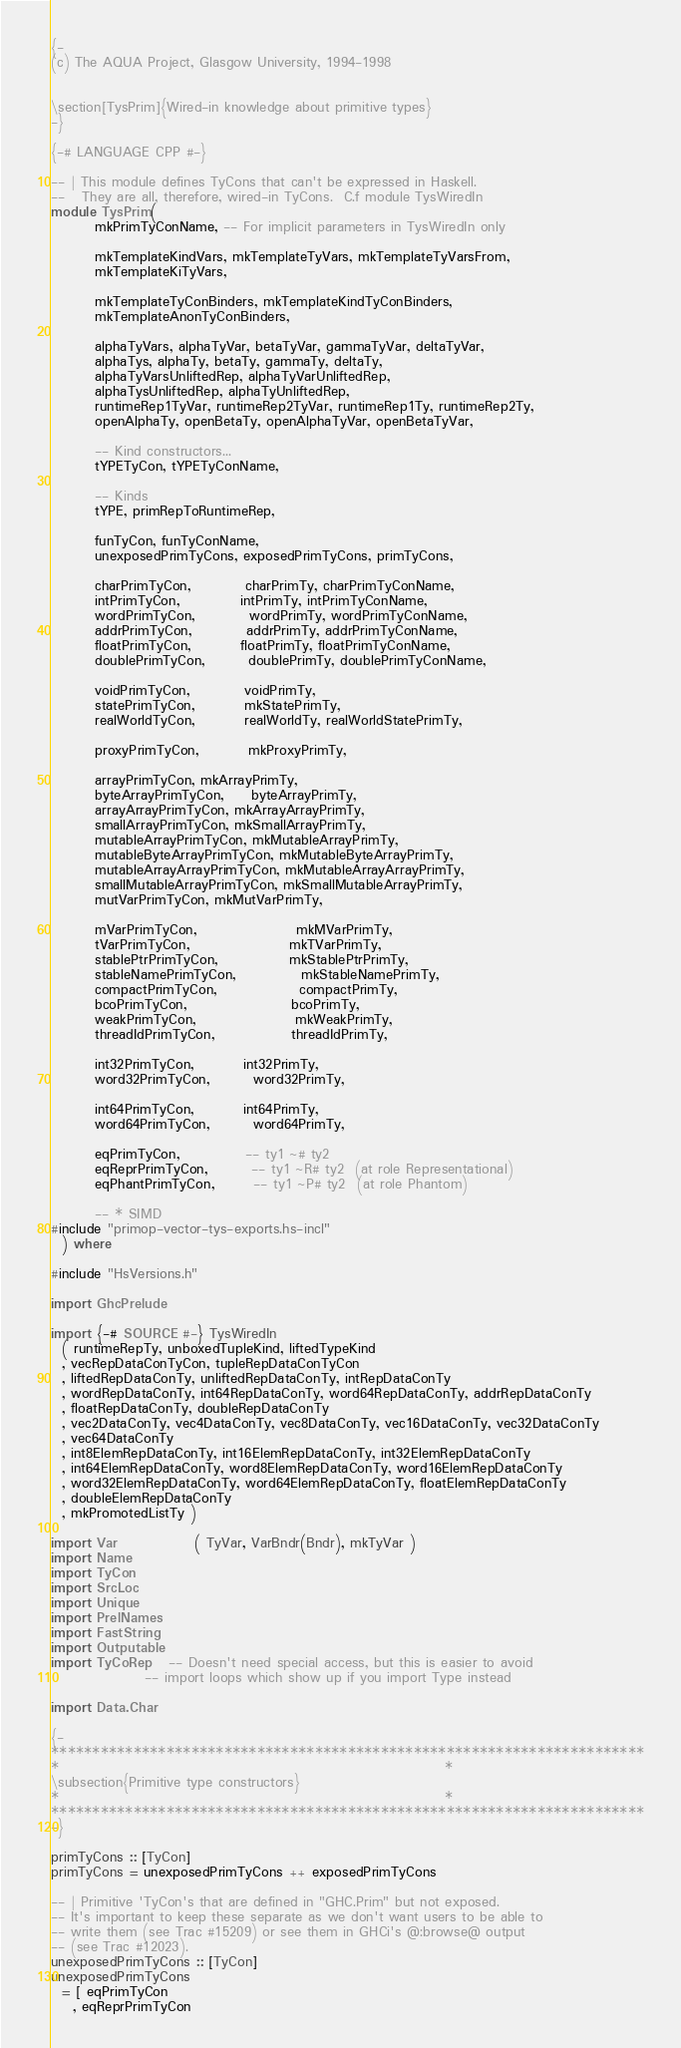Convert code to text. <code><loc_0><loc_0><loc_500><loc_500><_Haskell_>{-
(c) The AQUA Project, Glasgow University, 1994-1998


\section[TysPrim]{Wired-in knowledge about primitive types}
-}

{-# LANGUAGE CPP #-}

-- | This module defines TyCons that can't be expressed in Haskell.
--   They are all, therefore, wired-in TyCons.  C.f module TysWiredIn
module TysPrim(
        mkPrimTyConName, -- For implicit parameters in TysWiredIn only

        mkTemplateKindVars, mkTemplateTyVars, mkTemplateTyVarsFrom,
        mkTemplateKiTyVars,

        mkTemplateTyConBinders, mkTemplateKindTyConBinders,
        mkTemplateAnonTyConBinders,

        alphaTyVars, alphaTyVar, betaTyVar, gammaTyVar, deltaTyVar,
        alphaTys, alphaTy, betaTy, gammaTy, deltaTy,
        alphaTyVarsUnliftedRep, alphaTyVarUnliftedRep,
        alphaTysUnliftedRep, alphaTyUnliftedRep,
        runtimeRep1TyVar, runtimeRep2TyVar, runtimeRep1Ty, runtimeRep2Ty,
        openAlphaTy, openBetaTy, openAlphaTyVar, openBetaTyVar,

        -- Kind constructors...
        tYPETyCon, tYPETyConName,

        -- Kinds
        tYPE, primRepToRuntimeRep,

        funTyCon, funTyConName,
        unexposedPrimTyCons, exposedPrimTyCons, primTyCons,

        charPrimTyCon,          charPrimTy, charPrimTyConName,
        intPrimTyCon,           intPrimTy, intPrimTyConName,
        wordPrimTyCon,          wordPrimTy, wordPrimTyConName,
        addrPrimTyCon,          addrPrimTy, addrPrimTyConName,
        floatPrimTyCon,         floatPrimTy, floatPrimTyConName,
        doublePrimTyCon,        doublePrimTy, doublePrimTyConName,

        voidPrimTyCon,          voidPrimTy,
        statePrimTyCon,         mkStatePrimTy,
        realWorldTyCon,         realWorldTy, realWorldStatePrimTy,

        proxyPrimTyCon,         mkProxyPrimTy,

        arrayPrimTyCon, mkArrayPrimTy,
        byteArrayPrimTyCon,     byteArrayPrimTy,
        arrayArrayPrimTyCon, mkArrayArrayPrimTy,
        smallArrayPrimTyCon, mkSmallArrayPrimTy,
        mutableArrayPrimTyCon, mkMutableArrayPrimTy,
        mutableByteArrayPrimTyCon, mkMutableByteArrayPrimTy,
        mutableArrayArrayPrimTyCon, mkMutableArrayArrayPrimTy,
        smallMutableArrayPrimTyCon, mkSmallMutableArrayPrimTy,
        mutVarPrimTyCon, mkMutVarPrimTy,

        mVarPrimTyCon,                  mkMVarPrimTy,
        tVarPrimTyCon,                  mkTVarPrimTy,
        stablePtrPrimTyCon,             mkStablePtrPrimTy,
        stableNamePrimTyCon,            mkStableNamePrimTy,
        compactPrimTyCon,               compactPrimTy,
        bcoPrimTyCon,                   bcoPrimTy,
        weakPrimTyCon,                  mkWeakPrimTy,
        threadIdPrimTyCon,              threadIdPrimTy,

        int32PrimTyCon,         int32PrimTy,
        word32PrimTyCon,        word32PrimTy,

        int64PrimTyCon,         int64PrimTy,
        word64PrimTyCon,        word64PrimTy,

        eqPrimTyCon,            -- ty1 ~# ty2
        eqReprPrimTyCon,        -- ty1 ~R# ty2  (at role Representational)
        eqPhantPrimTyCon,       -- ty1 ~P# ty2  (at role Phantom)

        -- * SIMD
#include "primop-vector-tys-exports.hs-incl"
  ) where

#include "HsVersions.h"

import GhcPrelude

import {-# SOURCE #-} TysWiredIn
  ( runtimeRepTy, unboxedTupleKind, liftedTypeKind
  , vecRepDataConTyCon, tupleRepDataConTyCon
  , liftedRepDataConTy, unliftedRepDataConTy, intRepDataConTy
  , wordRepDataConTy, int64RepDataConTy, word64RepDataConTy, addrRepDataConTy
  , floatRepDataConTy, doubleRepDataConTy
  , vec2DataConTy, vec4DataConTy, vec8DataConTy, vec16DataConTy, vec32DataConTy
  , vec64DataConTy
  , int8ElemRepDataConTy, int16ElemRepDataConTy, int32ElemRepDataConTy
  , int64ElemRepDataConTy, word8ElemRepDataConTy, word16ElemRepDataConTy
  , word32ElemRepDataConTy, word64ElemRepDataConTy, floatElemRepDataConTy
  , doubleElemRepDataConTy
  , mkPromotedListTy )

import Var              ( TyVar, VarBndr(Bndr), mkTyVar )
import Name
import TyCon
import SrcLoc
import Unique
import PrelNames
import FastString
import Outputable
import TyCoRep   -- Doesn't need special access, but this is easier to avoid
                 -- import loops which show up if you import Type instead

import Data.Char

{-
************************************************************************
*                                                                      *
\subsection{Primitive type constructors}
*                                                                      *
************************************************************************
-}

primTyCons :: [TyCon]
primTyCons = unexposedPrimTyCons ++ exposedPrimTyCons

-- | Primitive 'TyCon's that are defined in "GHC.Prim" but not exposed.
-- It's important to keep these separate as we don't want users to be able to
-- write them (see Trac #15209) or see them in GHCi's @:browse@ output
-- (see Trac #12023).
unexposedPrimTyCons :: [TyCon]
unexposedPrimTyCons
  = [ eqPrimTyCon
    , eqReprPrimTyCon</code> 